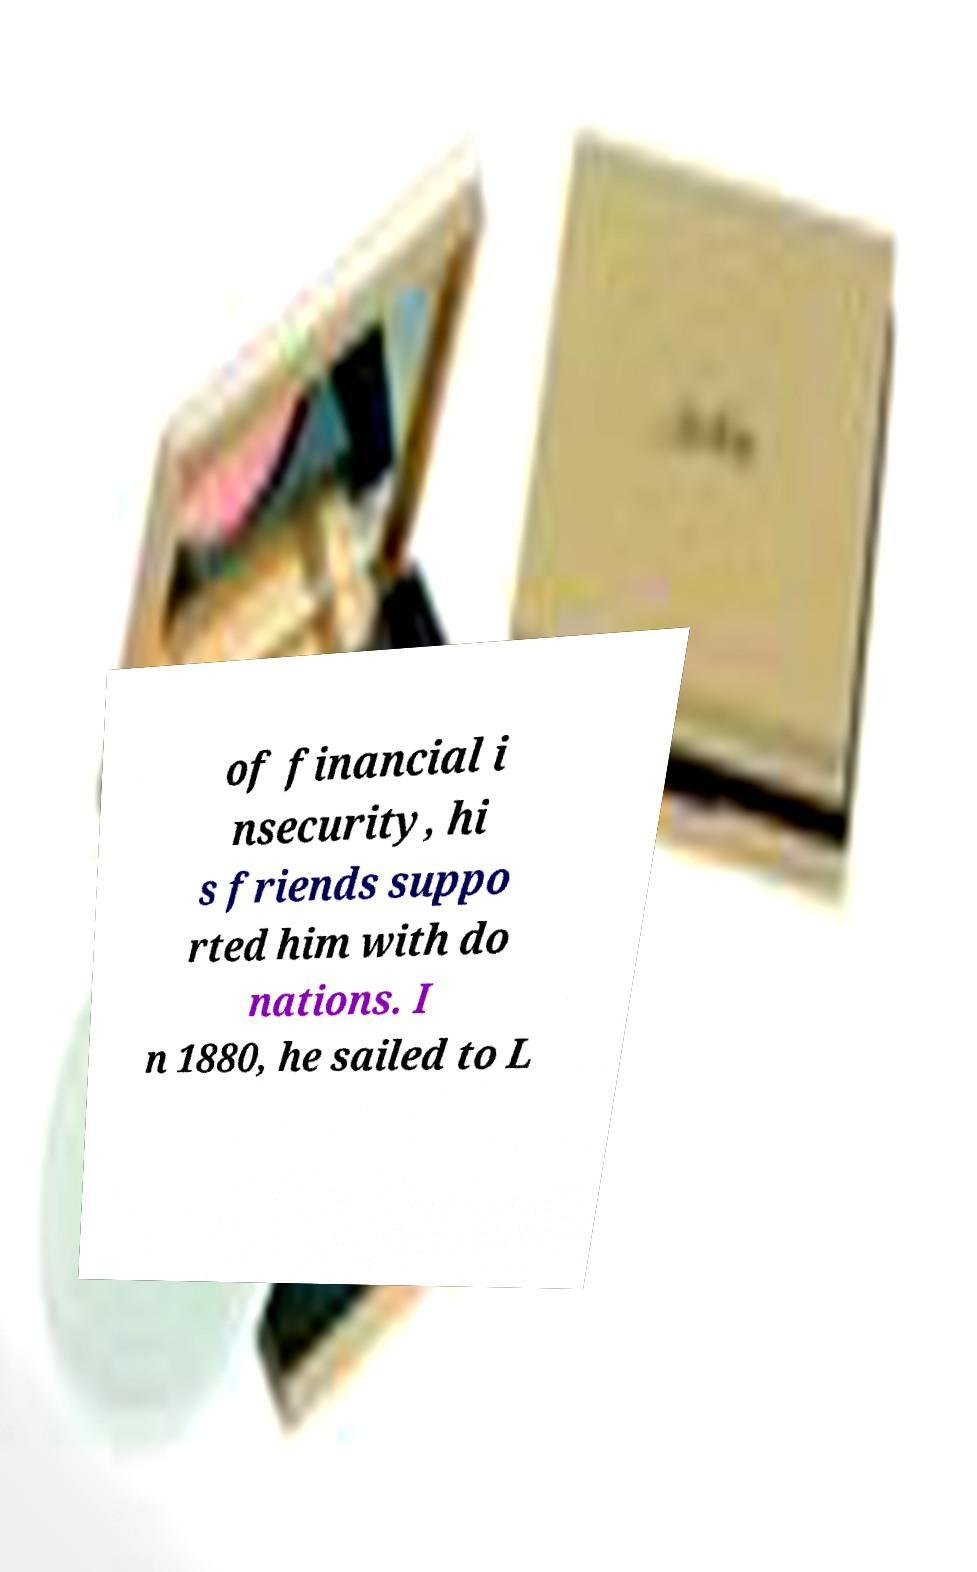Could you extract and type out the text from this image? of financial i nsecurity, hi s friends suppo rted him with do nations. I n 1880, he sailed to L 